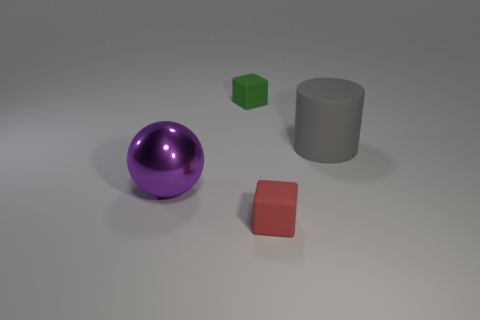There is a small object in front of the large rubber thing; is it the same shape as the large purple object? No, the small object in front of the large rubber cylinder is a cube, which has six faces and edges at right angles, whereas the large purple object is a sphere, characterized by its smooth, round surface with no edges. 